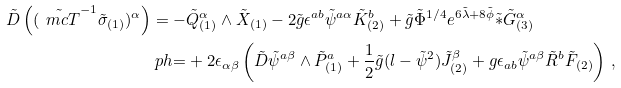Convert formula to latex. <formula><loc_0><loc_0><loc_500><loc_500>\tilde { D } \left ( ( \tilde { \ m c { T } } ^ { - 1 } \tilde { \sigma } _ { ( 1 ) } ) ^ { \alpha } \right ) & = - \tilde { Q } ^ { \alpha } _ { ( 1 ) } \wedge \tilde { X } _ { ( 1 ) } - 2 \tilde { g } \epsilon ^ { a b } \tilde { \psi } ^ { a \alpha } \tilde { K } ^ { b } _ { ( 2 ) } + \tilde { g } \tilde { \Phi } ^ { 1 / 4 } e ^ { 6 \tilde { \lambda } + 8 \tilde { \phi } } \tilde { \ast } \tilde { G } ^ { \alpha } _ { ( 3 ) } \\ & \ p h { = } + 2 \epsilon _ { \alpha \beta } \left ( \tilde { D } \tilde { \psi } ^ { a \beta } \wedge \tilde { P } ^ { a } _ { ( 1 ) } + \frac { 1 } { 2 } \tilde { g } ( l - \tilde { \psi } ^ { 2 } ) \tilde { J } ^ { \beta } _ { ( 2 ) } + g \epsilon _ { a b } \tilde { \psi } ^ { a \beta } \tilde { R } ^ { b } \tilde { F } _ { ( 2 ) } \right ) \, ,</formula> 